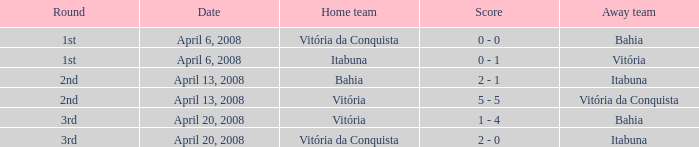What home team has a score of 5 - 5? Vitória. 